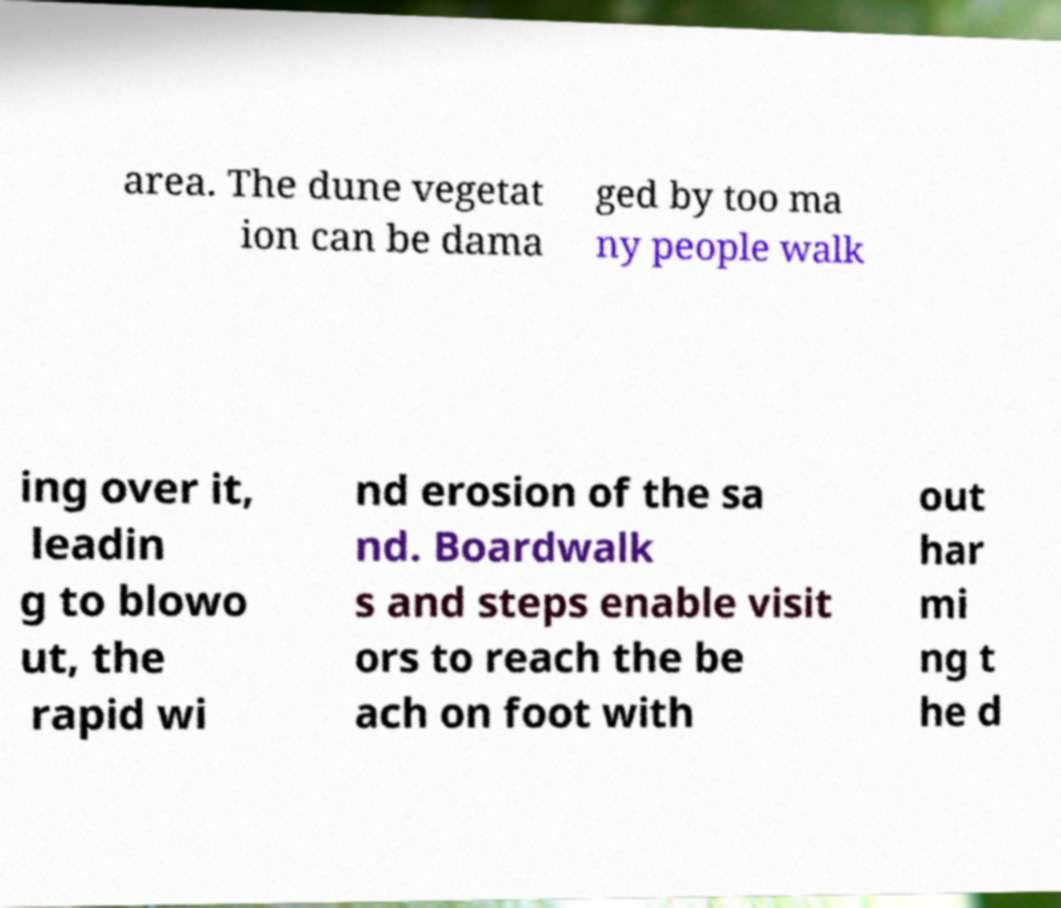What messages or text are displayed in this image? I need them in a readable, typed format. area. The dune vegetat ion can be dama ged by too ma ny people walk ing over it, leadin g to blowo ut, the rapid wi nd erosion of the sa nd. Boardwalk s and steps enable visit ors to reach the be ach on foot with out har mi ng t he d 